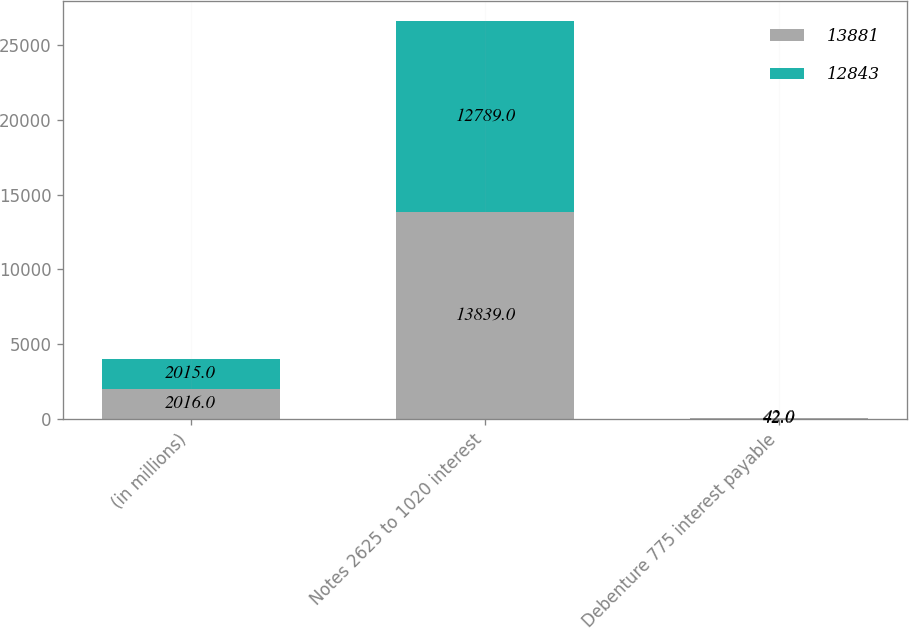<chart> <loc_0><loc_0><loc_500><loc_500><stacked_bar_chart><ecel><fcel>(in millions)<fcel>Notes 2625 to 1020 interest<fcel>Debenture 775 interest payable<nl><fcel>13881<fcel>2016<fcel>13839<fcel>42<nl><fcel>12843<fcel>2015<fcel>12789<fcel>42<nl></chart> 